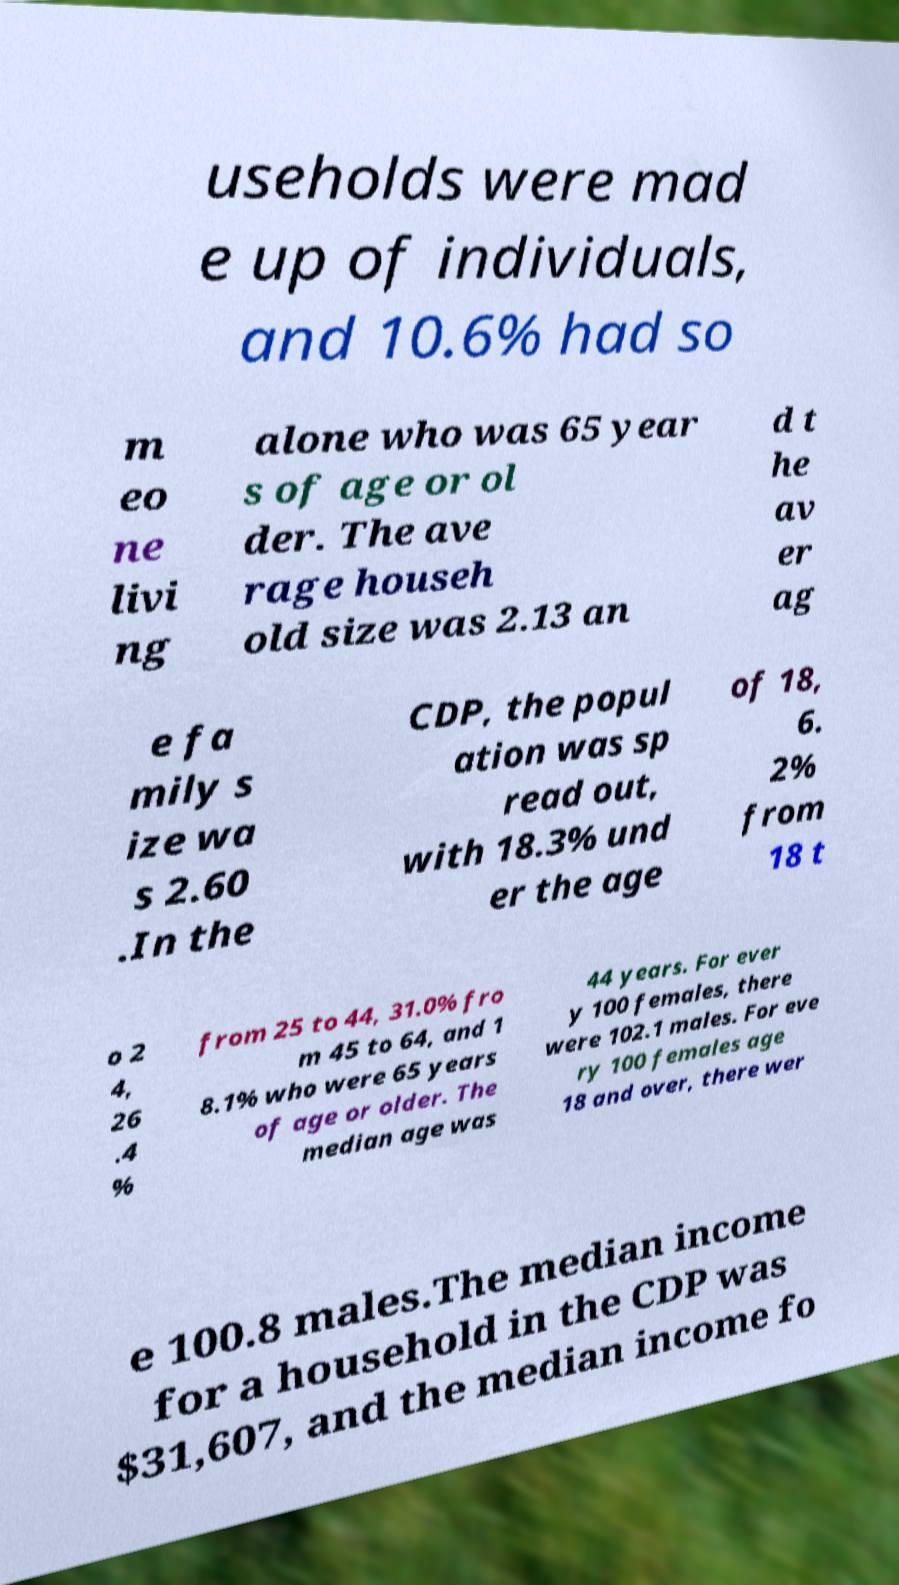Can you accurately transcribe the text from the provided image for me? useholds were mad e up of individuals, and 10.6% had so m eo ne livi ng alone who was 65 year s of age or ol der. The ave rage househ old size was 2.13 an d t he av er ag e fa mily s ize wa s 2.60 .In the CDP, the popul ation was sp read out, with 18.3% und er the age of 18, 6. 2% from 18 t o 2 4, 26 .4 % from 25 to 44, 31.0% fro m 45 to 64, and 1 8.1% who were 65 years of age or older. The median age was 44 years. For ever y 100 females, there were 102.1 males. For eve ry 100 females age 18 and over, there wer e 100.8 males.The median income for a household in the CDP was $31,607, and the median income fo 